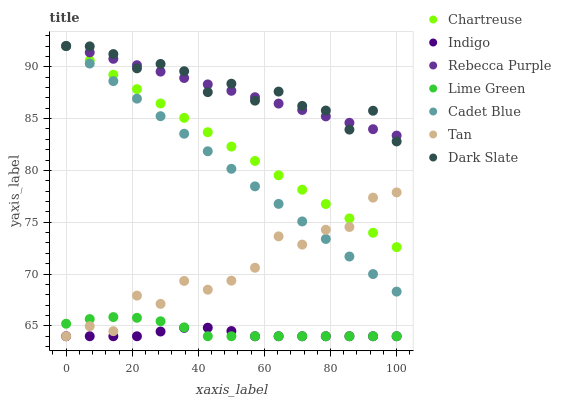Does Indigo have the minimum area under the curve?
Answer yes or no. Yes. Does Dark Slate have the maximum area under the curve?
Answer yes or no. Yes. Does Dark Slate have the minimum area under the curve?
Answer yes or no. No. Does Indigo have the maximum area under the curve?
Answer yes or no. No. Is Chartreuse the smoothest?
Answer yes or no. Yes. Is Tan the roughest?
Answer yes or no. Yes. Is Indigo the smoothest?
Answer yes or no. No. Is Indigo the roughest?
Answer yes or no. No. Does Indigo have the lowest value?
Answer yes or no. Yes. Does Dark Slate have the lowest value?
Answer yes or no. No. Does Rebecca Purple have the highest value?
Answer yes or no. Yes. Does Indigo have the highest value?
Answer yes or no. No. Is Lime Green less than Rebecca Purple?
Answer yes or no. Yes. Is Chartreuse greater than Lime Green?
Answer yes or no. Yes. Does Chartreuse intersect Tan?
Answer yes or no. Yes. Is Chartreuse less than Tan?
Answer yes or no. No. Is Chartreuse greater than Tan?
Answer yes or no. No. Does Lime Green intersect Rebecca Purple?
Answer yes or no. No. 